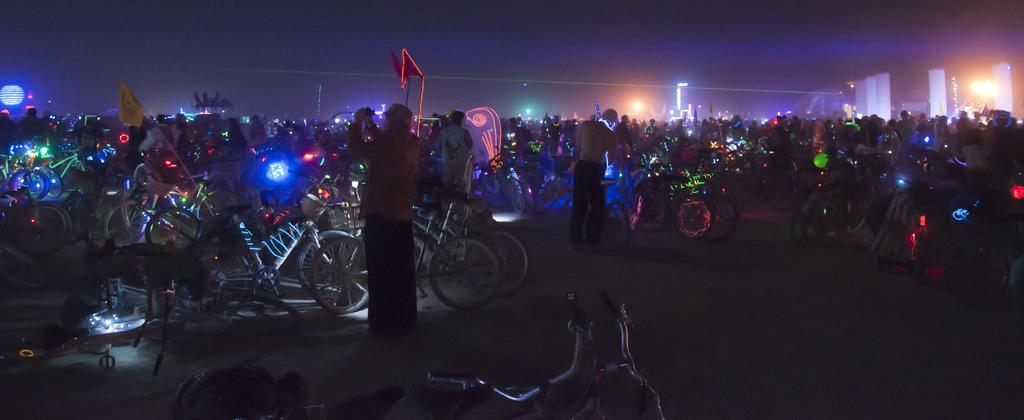How many people are present in the image? There are many people in the image. What can be seen besides the people in the image? There are bicycles in the image. What time of day is depicted in the image? The image is taken at nighttime. Is there any symbol or emblem present in the image? Yes, there is a flag in the image. What type of flame can be seen on the bicycles in the image? There are no flames present on the bicycles in the image. What color are the socks worn by the people in the image? There is no information about socks or their colors in the image. 